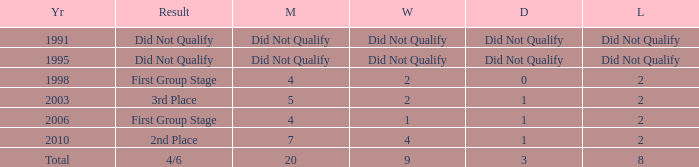How many draws were there in 2006? 1.0. 